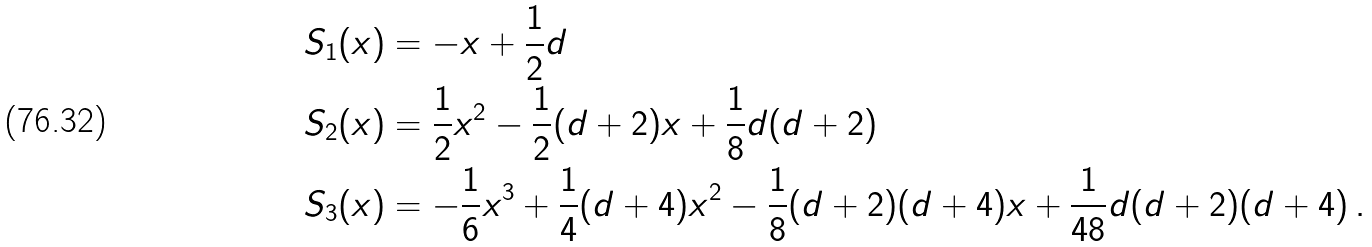<formula> <loc_0><loc_0><loc_500><loc_500>S _ { 1 } ( x ) & = - x + \frac { 1 } { 2 } d \\ S _ { 2 } ( x ) & = \frac { 1 } { 2 } x ^ { 2 } - \frac { 1 } { 2 } ( d + 2 ) x + \frac { 1 } { 8 } d ( d + 2 ) \\ S _ { 3 } ( x ) & = - \frac { 1 } { 6 } x ^ { 3 } + \frac { 1 } { 4 } ( d + 4 ) x ^ { 2 } - \frac { 1 } { 8 } ( d + 2 ) ( d + 4 ) x + \frac { 1 } { 4 8 } d ( d + 2 ) ( d + 4 ) \, .</formula> 